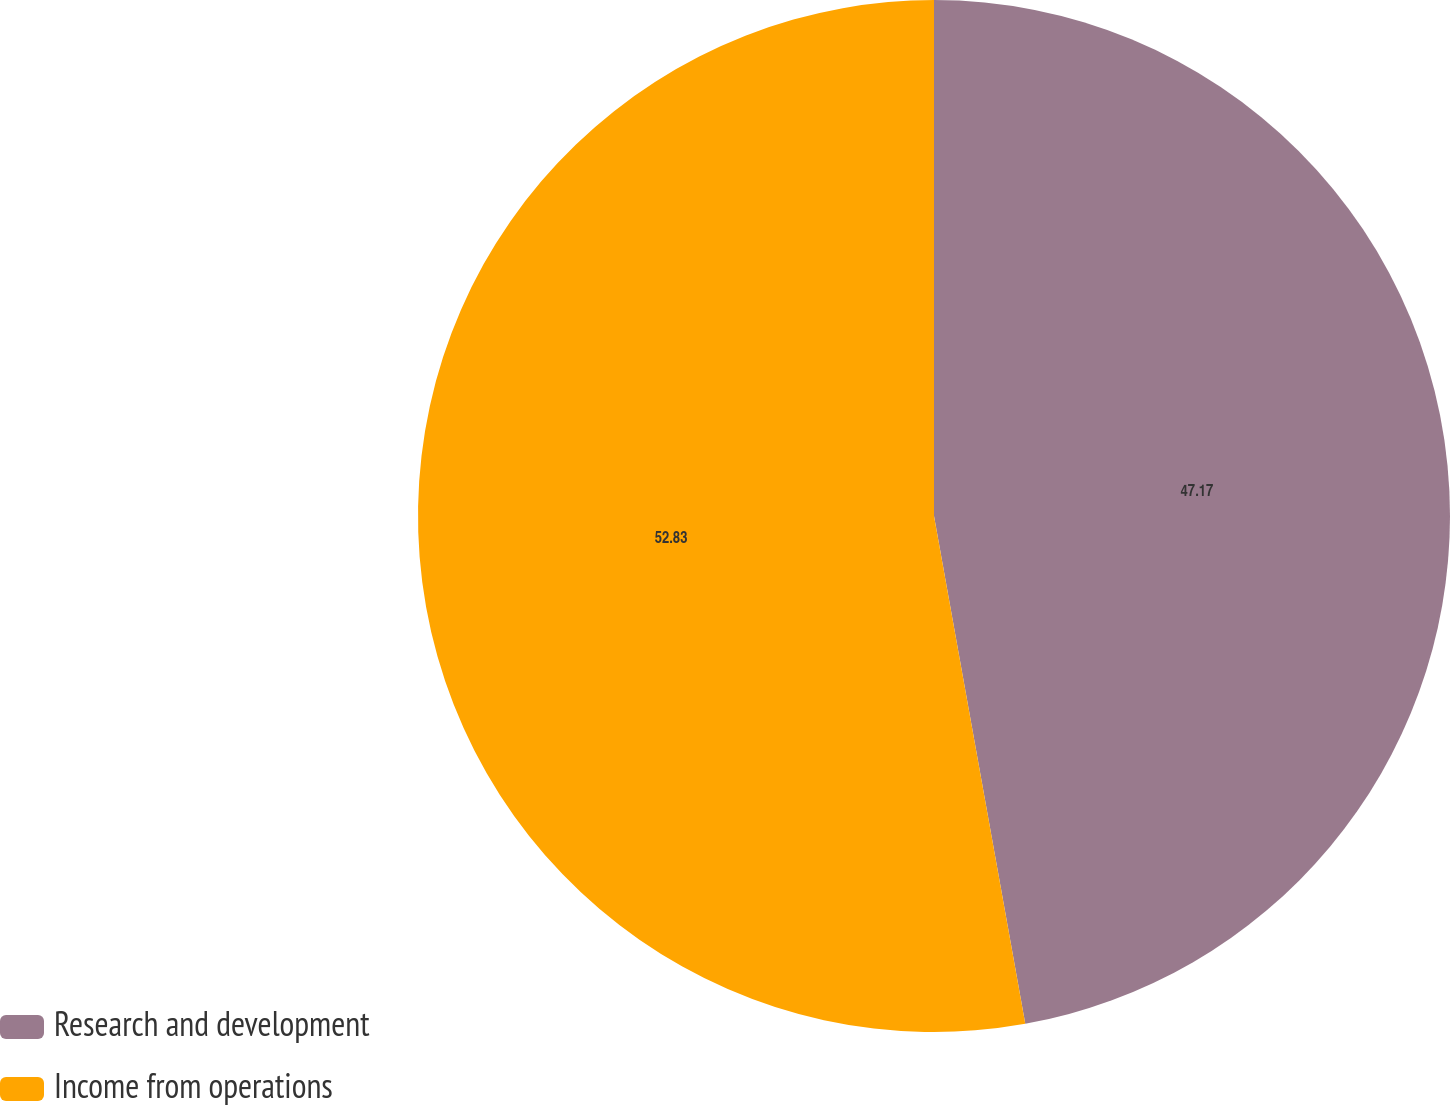<chart> <loc_0><loc_0><loc_500><loc_500><pie_chart><fcel>Research and development<fcel>Income from operations<nl><fcel>47.17%<fcel>52.83%<nl></chart> 